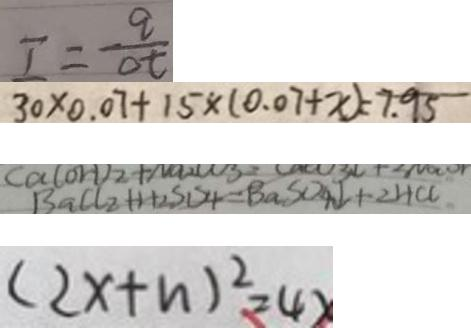<formula> <loc_0><loc_0><loc_500><loc_500>I = \frac { q } { \Delta t } 
 3 0 \times 0 . 0 7 + 1 5 \times ( 0 . 0 7 + x ) = 7 . 9 5 
 B a C l _ { 2 } + H _ { 2 } S D _ { 4 } = B a S O _ { 4 } \downarrow + 2 H C C 
 ( 2 x + n ) ^ { 2 } = 4 x</formula> 